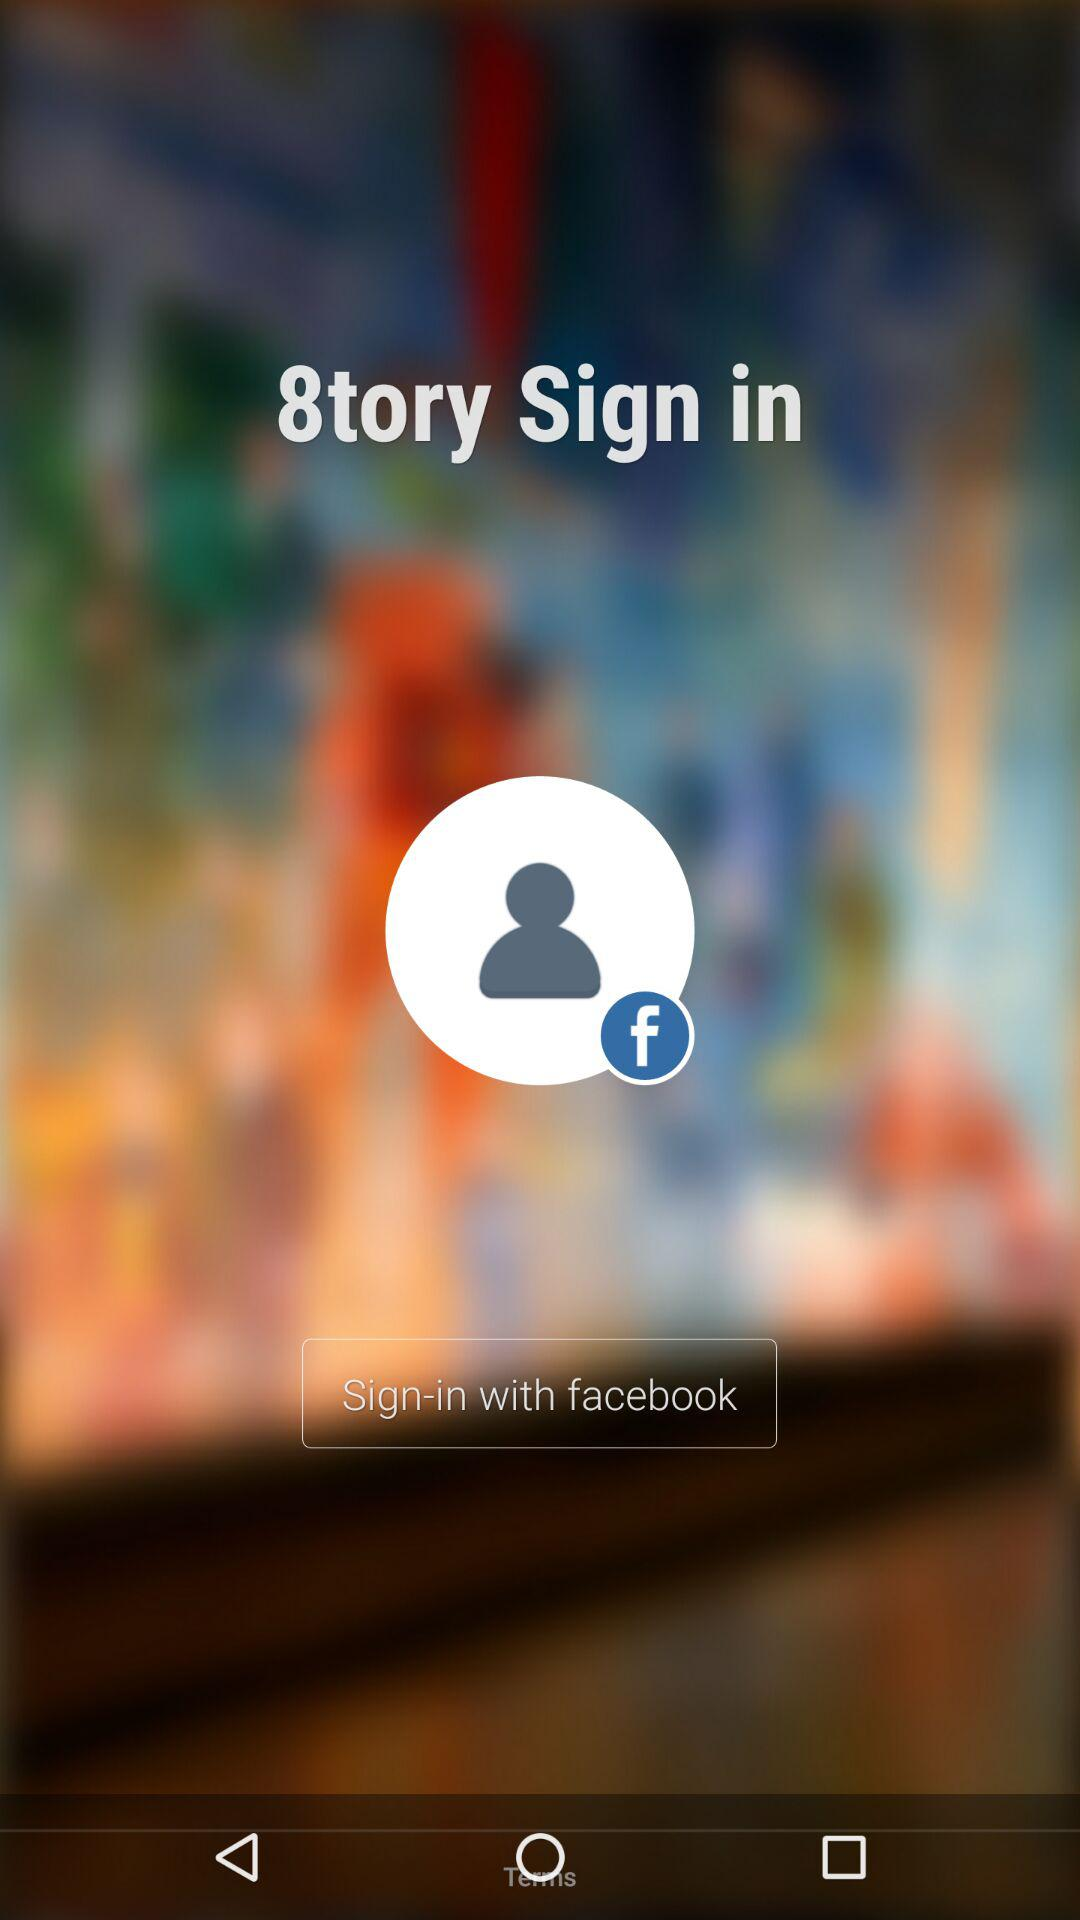What account can be used to sign in? The account that can be used to sign in is "facebook". 